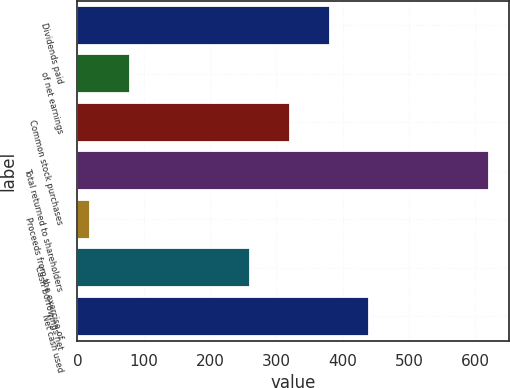<chart> <loc_0><loc_0><loc_500><loc_500><bar_chart><fcel>Dividends paid<fcel>of net earnings<fcel>Common stock purchases<fcel>Total returned to shareholders<fcel>Proceeds from the exercise of<fcel>Cash borrowings net<fcel>Net cash used<nl><fcel>380.18<fcel>79.19<fcel>320.09<fcel>620<fcel>19.1<fcel>260<fcel>440.27<nl></chart> 